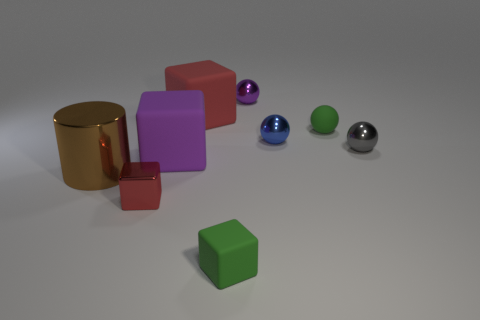Is there a tiny blue ball made of the same material as the small green sphere?
Ensure brevity in your answer.  No. There is a metal object behind the green thing behind the small gray shiny thing; what is its size?
Provide a succinct answer. Small. Are there more green things than small purple metallic spheres?
Offer a very short reply. Yes. There is a red cube that is behind the red metal object; does it have the same size as the small red shiny cube?
Make the answer very short. No. How many cubes are the same color as the small rubber ball?
Your response must be concise. 1. Does the small gray thing have the same shape as the small blue object?
Offer a terse response. Yes. What is the size of the red matte object that is the same shape as the large purple object?
Provide a succinct answer. Large. Are there more tiny red shiny things that are to the right of the tiny metallic block than blue balls that are to the right of the large brown thing?
Give a very brief answer. No. Do the brown cylinder and the sphere that is in front of the tiny blue shiny sphere have the same material?
Provide a succinct answer. Yes. Is there anything else that is the same shape as the large metallic object?
Ensure brevity in your answer.  No. 